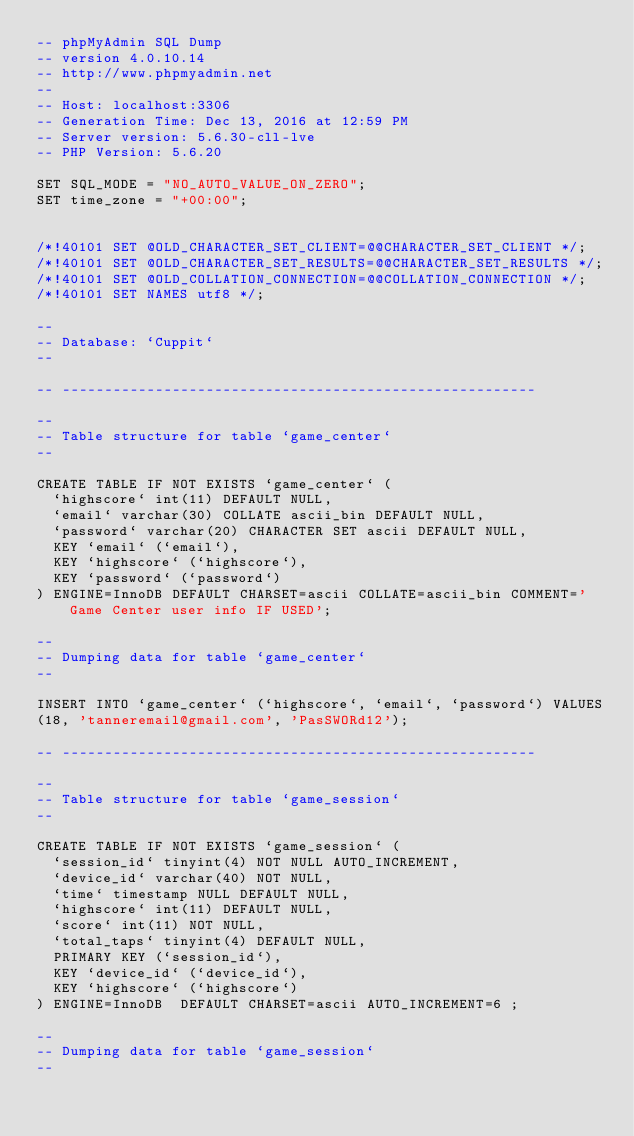<code> <loc_0><loc_0><loc_500><loc_500><_SQL_>-- phpMyAdmin SQL Dump
-- version 4.0.10.14
-- http://www.phpmyadmin.net
--
-- Host: localhost:3306
-- Generation Time: Dec 13, 2016 at 12:59 PM
-- Server version: 5.6.30-cll-lve
-- PHP Version: 5.6.20

SET SQL_MODE = "NO_AUTO_VALUE_ON_ZERO";
SET time_zone = "+00:00";


/*!40101 SET @OLD_CHARACTER_SET_CLIENT=@@CHARACTER_SET_CLIENT */;
/*!40101 SET @OLD_CHARACTER_SET_RESULTS=@@CHARACTER_SET_RESULTS */;
/*!40101 SET @OLD_COLLATION_CONNECTION=@@COLLATION_CONNECTION */;
/*!40101 SET NAMES utf8 */;

--
-- Database: `Cuppit`
--

-- --------------------------------------------------------

--
-- Table structure for table `game_center`
--

CREATE TABLE IF NOT EXISTS `game_center` (
  `highscore` int(11) DEFAULT NULL,
  `email` varchar(30) COLLATE ascii_bin DEFAULT NULL,
  `password` varchar(20) CHARACTER SET ascii DEFAULT NULL,
  KEY `email` (`email`),
  KEY `highscore` (`highscore`),
  KEY `password` (`password`)
) ENGINE=InnoDB DEFAULT CHARSET=ascii COLLATE=ascii_bin COMMENT='Game Center user info IF USED';

--
-- Dumping data for table `game_center`
--

INSERT INTO `game_center` (`highscore`, `email`, `password`) VALUES
(18, 'tanneremail@gmail.com', 'PasSWORd12');

-- --------------------------------------------------------

--
-- Table structure for table `game_session`
--

CREATE TABLE IF NOT EXISTS `game_session` (
  `session_id` tinyint(4) NOT NULL AUTO_INCREMENT,
  `device_id` varchar(40) NOT NULL,
  `time` timestamp NULL DEFAULT NULL,
  `highscore` int(11) DEFAULT NULL,
  `score` int(11) NOT NULL,
  `total_taps` tinyint(4) DEFAULT NULL,
  PRIMARY KEY (`session_id`),
  KEY `device_id` (`device_id`),
  KEY `highscore` (`highscore`)
) ENGINE=InnoDB  DEFAULT CHARSET=ascii AUTO_INCREMENT=6 ;

--
-- Dumping data for table `game_session`
--
</code> 